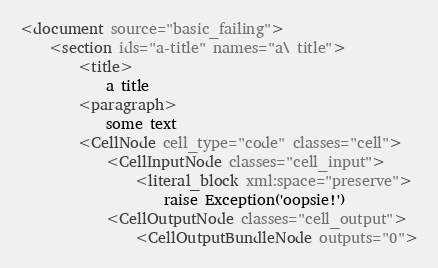<code> <loc_0><loc_0><loc_500><loc_500><_XML_><document source="basic_failing">
    <section ids="a-title" names="a\ title">
        <title>
            a title
        <paragraph>
            some text
        <CellNode cell_type="code" classes="cell">
            <CellInputNode classes="cell_input">
                <literal_block xml:space="preserve">
                    raise Exception('oopsie!')
            <CellOutputNode classes="cell_output">
                <CellOutputBundleNode outputs="0">
</code> 